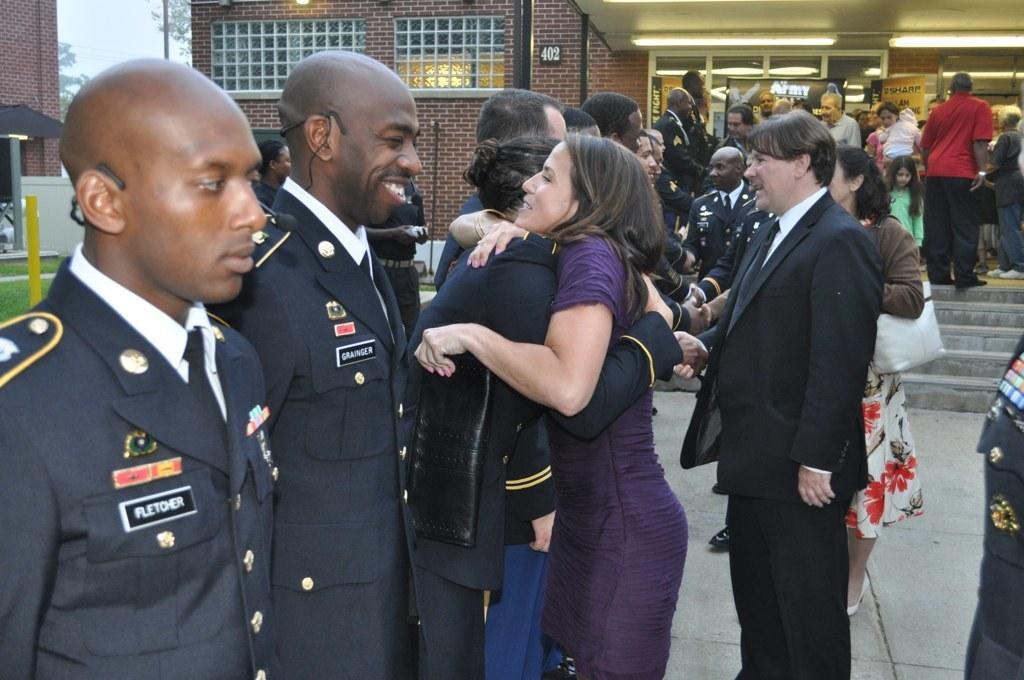Could you give a brief overview of what you see in this image? In the image there are many people standing. There are few people with uniforms. In between them there are steps. In the background there are walls with windows, glass doors, posters with text and other things. On the left side of the image there is a wall, pole and also there are leaves. 